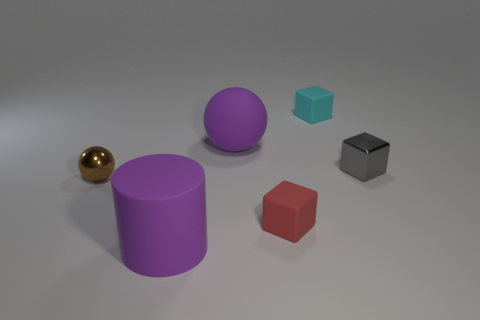There is a small gray shiny cube; how many tiny brown shiny objects are behind it?
Keep it short and to the point. 0. There is a big object that is the same color as the large rubber cylinder; what is its shape?
Keep it short and to the point. Sphere. Are there any big purple objects behind the big thing that is behind the thing in front of the small red matte object?
Make the answer very short. No. Do the purple matte cylinder and the gray object have the same size?
Make the answer very short. No. Are there an equal number of tiny shiny spheres behind the gray metallic thing and gray metallic objects to the left of the large purple matte cylinder?
Provide a succinct answer. Yes. The red object to the right of the metal sphere has what shape?
Offer a terse response. Cube. What shape is the gray thing that is the same size as the brown thing?
Provide a short and direct response. Cube. What color is the big matte thing that is in front of the purple object behind the big thing in front of the brown shiny thing?
Provide a succinct answer. Purple. Is the tiny cyan object the same shape as the tiny gray shiny object?
Your response must be concise. Yes. Are there an equal number of large purple cylinders that are right of the cylinder and small brown spheres?
Offer a terse response. No. 